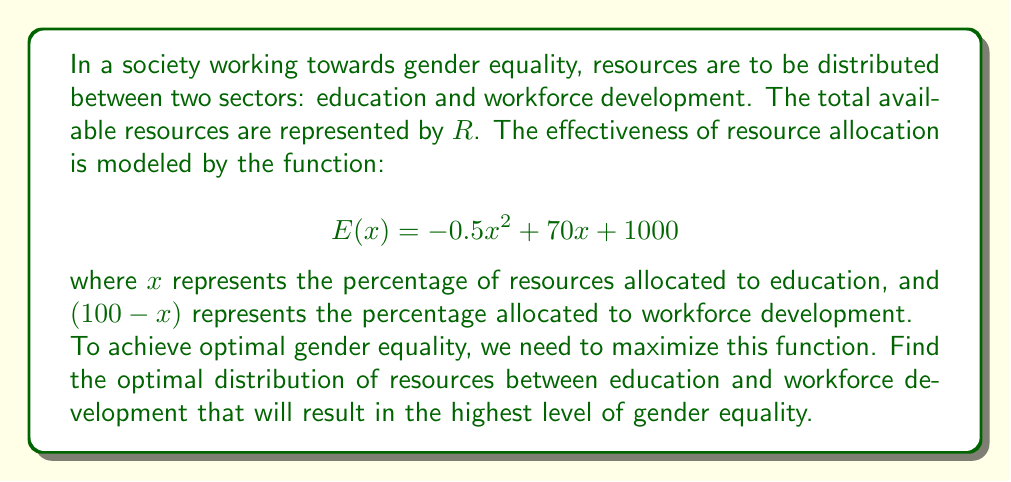Can you answer this question? To find the optimal distribution, we need to maximize the function $E(x)$. This can be done by finding the vertex of the parabola described by the quadratic function.

For a quadratic function in the form $f(x) = ax^2 + bx + c$, the x-coordinate of the vertex is given by $x = -\frac{b}{2a}$.

In our case:
$a = -0.5$
$b = 70$
$c = 1000$

Therefore:

$$ x = -\frac{70}{2(-0.5)} = -\frac{70}{-1} = 70 $$

This means that the optimal allocation is 70% to education and 30% to workforce development.

To verify this is a maximum (not a minimum), we can check that $a < 0$, which it is $(-0.5 < 0)$.

We can calculate the maximum value of $E(x)$ by substituting $x = 70$ into the original function:

$$ E(70) = -0.5(70)^2 + 70(70) + 1000 $$
$$ = -0.5(4900) + 4900 + 1000 $$
$$ = -2450 + 4900 + 1000 $$
$$ = 3450 $$

This represents the highest level of gender equality achievable with the given resources and model.
Answer: The optimal distribution is 70% of resources to education and 30% to workforce development, resulting in a maximum gender equality level of 3450 units. 